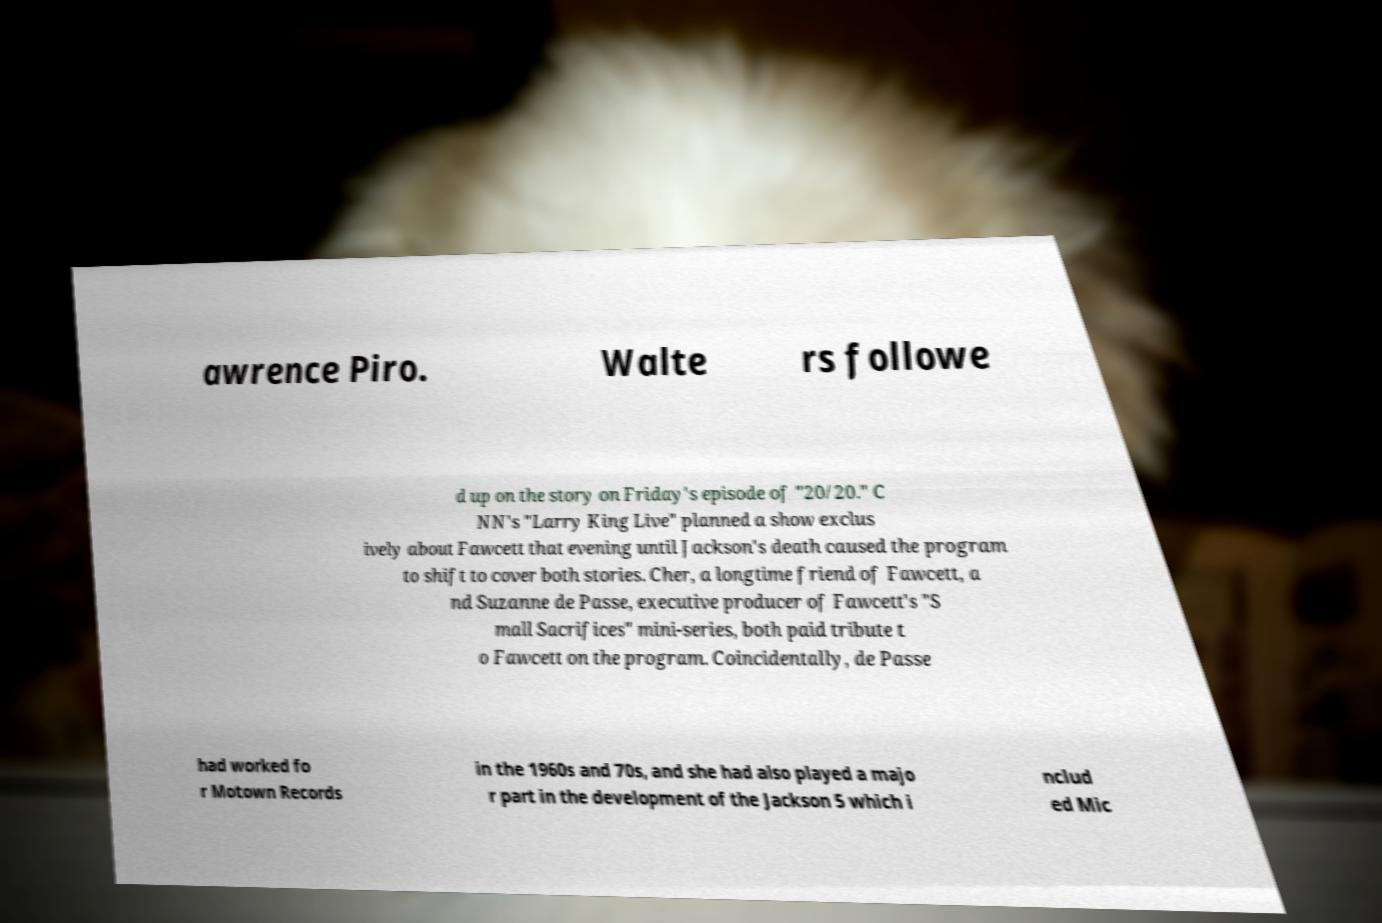There's text embedded in this image that I need extracted. Can you transcribe it verbatim? awrence Piro. Walte rs followe d up on the story on Friday's episode of "20/20." C NN's "Larry King Live" planned a show exclus ively about Fawcett that evening until Jackson's death caused the program to shift to cover both stories. Cher, a longtime friend of Fawcett, a nd Suzanne de Passe, executive producer of Fawcett's "S mall Sacrifices" mini-series, both paid tribute t o Fawcett on the program. Coincidentally, de Passe had worked fo r Motown Records in the 1960s and 70s, and she had also played a majo r part in the development of the Jackson 5 which i nclud ed Mic 